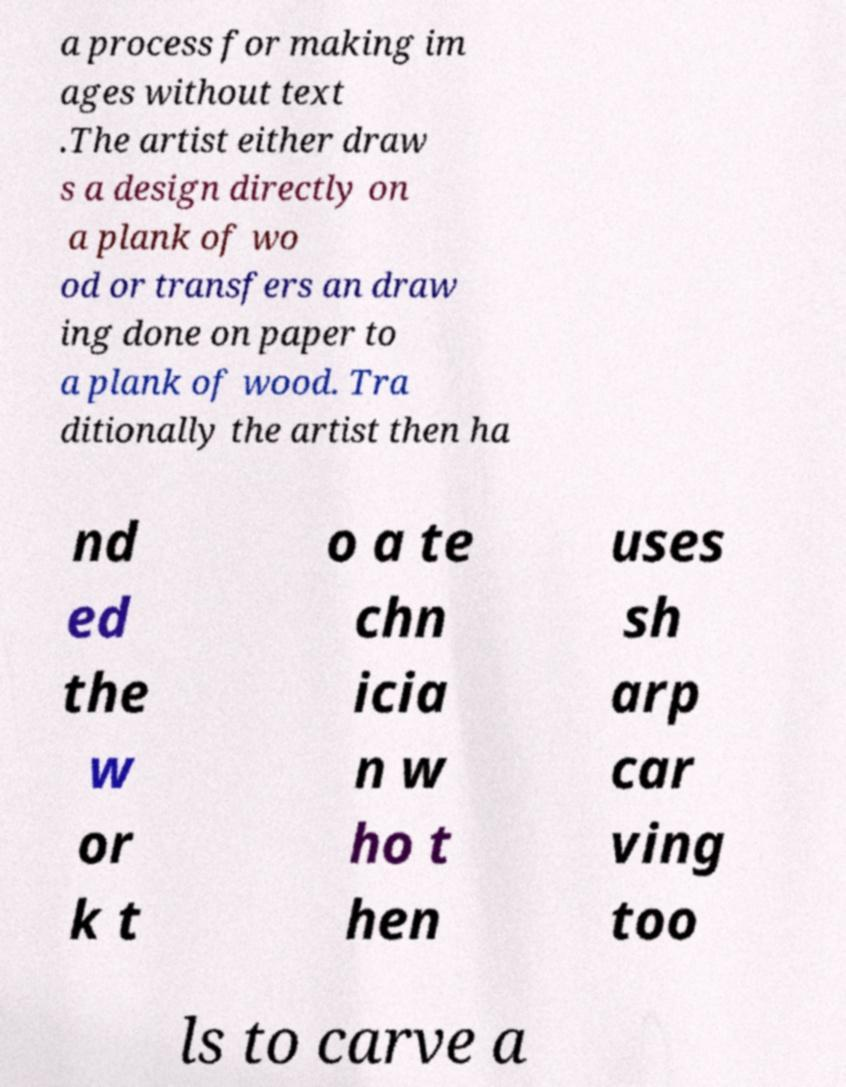Can you read and provide the text displayed in the image?This photo seems to have some interesting text. Can you extract and type it out for me? a process for making im ages without text .The artist either draw s a design directly on a plank of wo od or transfers an draw ing done on paper to a plank of wood. Tra ditionally the artist then ha nd ed the w or k t o a te chn icia n w ho t hen uses sh arp car ving too ls to carve a 